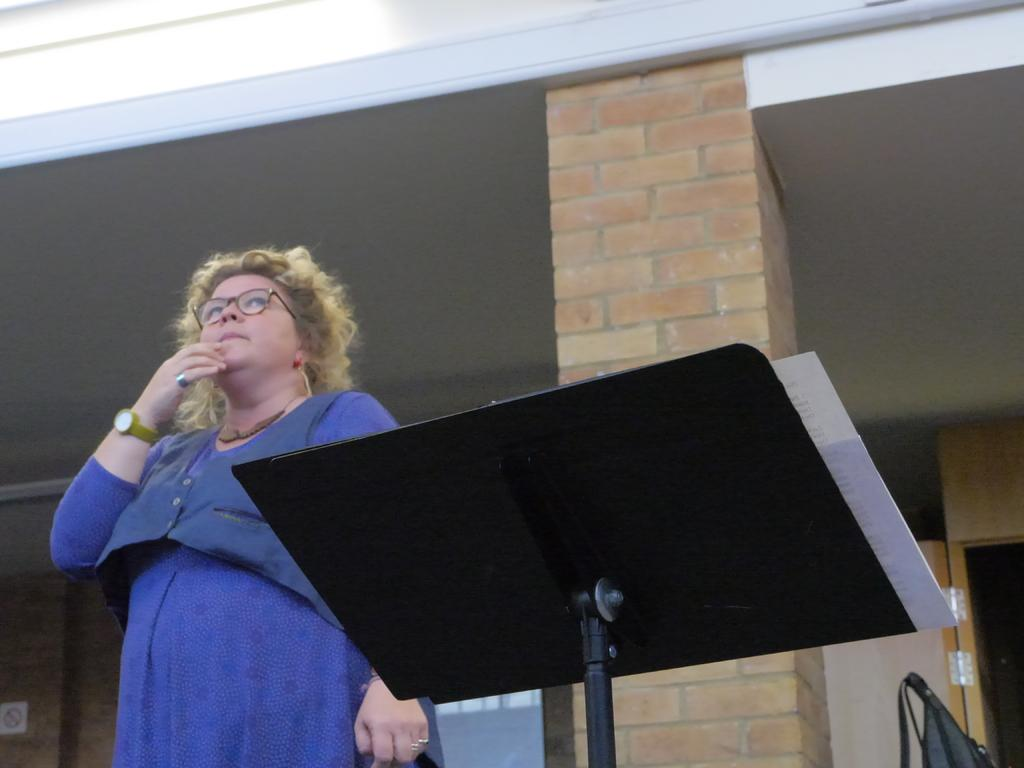What is the main subject in the image? There is a woman standing in the image. What object can be seen on the speaker stand? There is a paper on a speaker stand. What architectural feature is present in the image? There is a pillar in the image. What type of opening is visible in the image? There is a door in the image. What is attached to the wall in the image? There is a board on a wall in the image. What part of a building can be seen in the image? There is a roof visible in the image. What is the exchange rate between the two currencies depicted on the board in the image? There is no board depicting currency exchange rates in the image; the board mentioned in the facts is not related to currency exchange. 